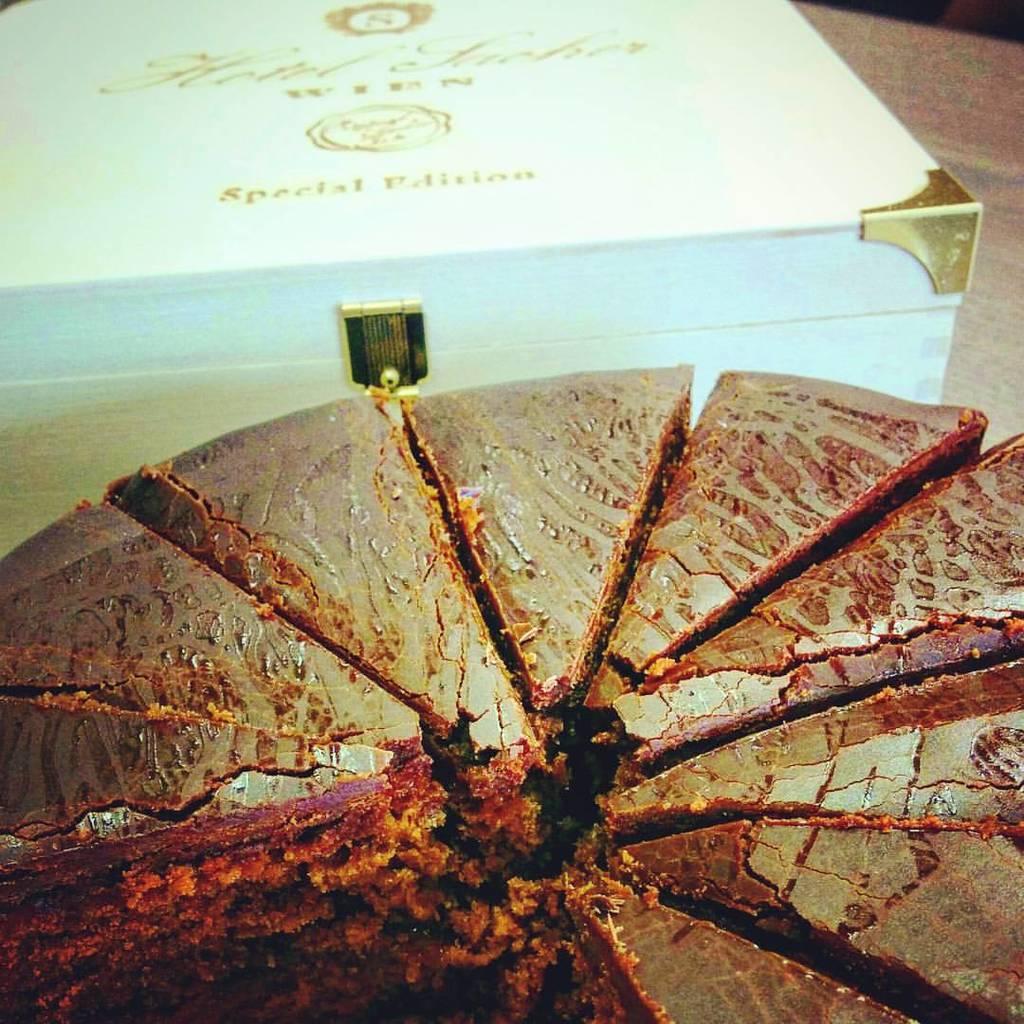Please provide a concise description of this image. At the bottom of this image I can see a cake which is cut into pieces. This is placed on a table. Beside this cake I can see a white color box. 